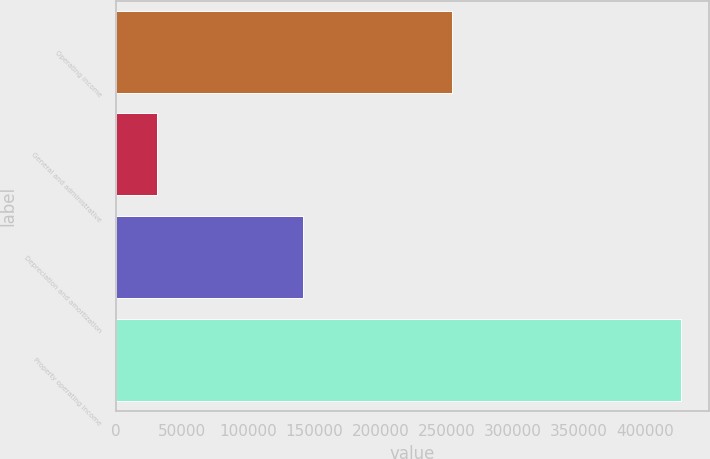Convert chart. <chart><loc_0><loc_0><loc_500><loc_500><bar_chart><fcel>Operating income<fcel>General and administrative<fcel>Depreciation and amortization<fcel>Property operating income<nl><fcel>253862<fcel>31158<fcel>141701<fcel>426721<nl></chart> 